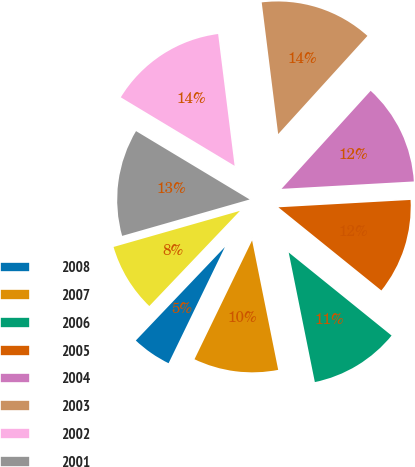Convert chart to OTSL. <chart><loc_0><loc_0><loc_500><loc_500><pie_chart><fcel>2008<fcel>2007<fcel>2006<fcel>2005<fcel>2004<fcel>2003<fcel>2002<fcel>2001<fcel>2000<nl><fcel>4.93%<fcel>10.35%<fcel>11.02%<fcel>11.7%<fcel>12.37%<fcel>13.72%<fcel>14.4%<fcel>13.05%<fcel>8.46%<nl></chart> 